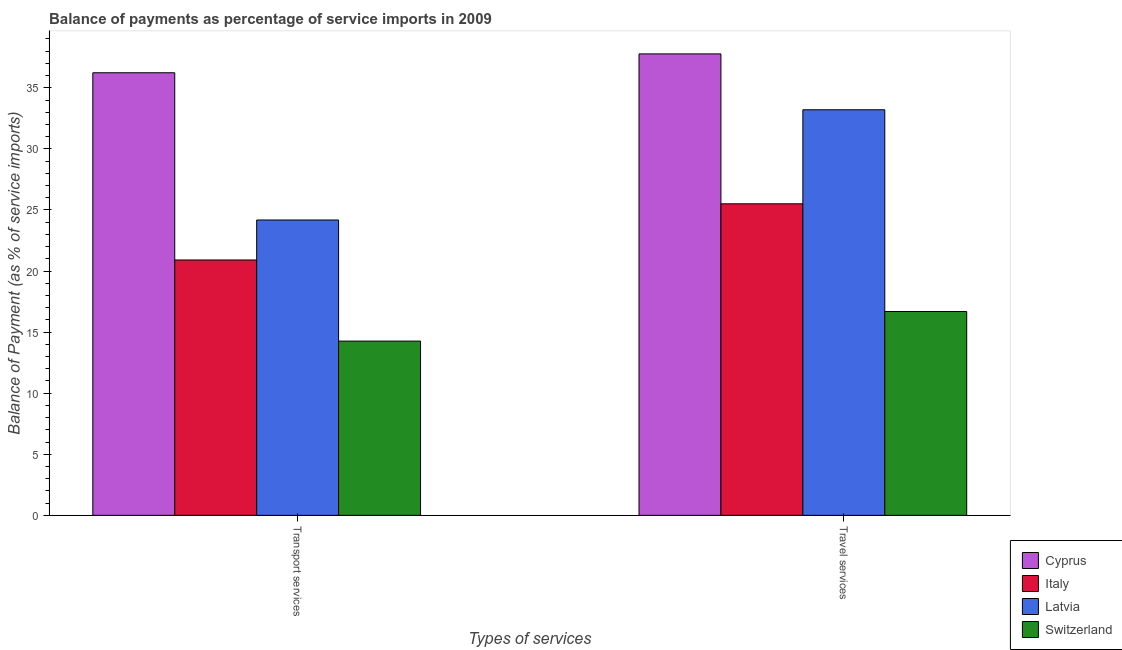How many different coloured bars are there?
Give a very brief answer. 4. How many groups of bars are there?
Ensure brevity in your answer.  2. Are the number of bars per tick equal to the number of legend labels?
Make the answer very short. Yes. How many bars are there on the 2nd tick from the right?
Your response must be concise. 4. What is the label of the 1st group of bars from the left?
Your response must be concise. Transport services. What is the balance of payments of transport services in Latvia?
Ensure brevity in your answer.  24.18. Across all countries, what is the maximum balance of payments of transport services?
Offer a very short reply. 36.23. Across all countries, what is the minimum balance of payments of transport services?
Your answer should be compact. 14.27. In which country was the balance of payments of transport services maximum?
Provide a short and direct response. Cyprus. In which country was the balance of payments of transport services minimum?
Ensure brevity in your answer.  Switzerland. What is the total balance of payments of travel services in the graph?
Offer a terse response. 113.17. What is the difference between the balance of payments of transport services in Latvia and that in Cyprus?
Ensure brevity in your answer.  -12.05. What is the difference between the balance of payments of transport services in Cyprus and the balance of payments of travel services in Switzerland?
Keep it short and to the point. 19.55. What is the average balance of payments of transport services per country?
Your answer should be compact. 23.9. What is the difference between the balance of payments of travel services and balance of payments of transport services in Switzerland?
Give a very brief answer. 2.42. What is the ratio of the balance of payments of transport services in Italy to that in Switzerland?
Give a very brief answer. 1.47. In how many countries, is the balance of payments of travel services greater than the average balance of payments of travel services taken over all countries?
Your response must be concise. 2. What does the 3rd bar from the left in Travel services represents?
Offer a terse response. Latvia. What does the 4th bar from the right in Travel services represents?
Your answer should be compact. Cyprus. How many countries are there in the graph?
Provide a short and direct response. 4. What is the difference between two consecutive major ticks on the Y-axis?
Provide a succinct answer. 5. How are the legend labels stacked?
Provide a short and direct response. Vertical. What is the title of the graph?
Keep it short and to the point. Balance of payments as percentage of service imports in 2009. What is the label or title of the X-axis?
Offer a very short reply. Types of services. What is the label or title of the Y-axis?
Keep it short and to the point. Balance of Payment (as % of service imports). What is the Balance of Payment (as % of service imports) of Cyprus in Transport services?
Give a very brief answer. 36.23. What is the Balance of Payment (as % of service imports) of Italy in Transport services?
Your answer should be very brief. 20.91. What is the Balance of Payment (as % of service imports) in Latvia in Transport services?
Provide a short and direct response. 24.18. What is the Balance of Payment (as % of service imports) in Switzerland in Transport services?
Make the answer very short. 14.27. What is the Balance of Payment (as % of service imports) of Cyprus in Travel services?
Provide a short and direct response. 37.78. What is the Balance of Payment (as % of service imports) in Italy in Travel services?
Your answer should be compact. 25.5. What is the Balance of Payment (as % of service imports) of Latvia in Travel services?
Make the answer very short. 33.2. What is the Balance of Payment (as % of service imports) in Switzerland in Travel services?
Ensure brevity in your answer.  16.69. Across all Types of services, what is the maximum Balance of Payment (as % of service imports) of Cyprus?
Provide a short and direct response. 37.78. Across all Types of services, what is the maximum Balance of Payment (as % of service imports) of Italy?
Keep it short and to the point. 25.5. Across all Types of services, what is the maximum Balance of Payment (as % of service imports) in Latvia?
Ensure brevity in your answer.  33.2. Across all Types of services, what is the maximum Balance of Payment (as % of service imports) of Switzerland?
Provide a short and direct response. 16.69. Across all Types of services, what is the minimum Balance of Payment (as % of service imports) of Cyprus?
Make the answer very short. 36.23. Across all Types of services, what is the minimum Balance of Payment (as % of service imports) in Italy?
Offer a very short reply. 20.91. Across all Types of services, what is the minimum Balance of Payment (as % of service imports) of Latvia?
Make the answer very short. 24.18. Across all Types of services, what is the minimum Balance of Payment (as % of service imports) of Switzerland?
Provide a short and direct response. 14.27. What is the total Balance of Payment (as % of service imports) of Cyprus in the graph?
Provide a short and direct response. 74.01. What is the total Balance of Payment (as % of service imports) in Italy in the graph?
Your answer should be very brief. 46.41. What is the total Balance of Payment (as % of service imports) in Latvia in the graph?
Make the answer very short. 57.38. What is the total Balance of Payment (as % of service imports) of Switzerland in the graph?
Provide a short and direct response. 30.95. What is the difference between the Balance of Payment (as % of service imports) of Cyprus in Transport services and that in Travel services?
Provide a succinct answer. -1.54. What is the difference between the Balance of Payment (as % of service imports) in Italy in Transport services and that in Travel services?
Your response must be concise. -4.6. What is the difference between the Balance of Payment (as % of service imports) of Latvia in Transport services and that in Travel services?
Offer a terse response. -9.02. What is the difference between the Balance of Payment (as % of service imports) in Switzerland in Transport services and that in Travel services?
Provide a succinct answer. -2.42. What is the difference between the Balance of Payment (as % of service imports) of Cyprus in Transport services and the Balance of Payment (as % of service imports) of Italy in Travel services?
Provide a short and direct response. 10.73. What is the difference between the Balance of Payment (as % of service imports) of Cyprus in Transport services and the Balance of Payment (as % of service imports) of Latvia in Travel services?
Offer a terse response. 3.03. What is the difference between the Balance of Payment (as % of service imports) of Cyprus in Transport services and the Balance of Payment (as % of service imports) of Switzerland in Travel services?
Give a very brief answer. 19.55. What is the difference between the Balance of Payment (as % of service imports) of Italy in Transport services and the Balance of Payment (as % of service imports) of Latvia in Travel services?
Give a very brief answer. -12.3. What is the difference between the Balance of Payment (as % of service imports) of Italy in Transport services and the Balance of Payment (as % of service imports) of Switzerland in Travel services?
Provide a succinct answer. 4.22. What is the difference between the Balance of Payment (as % of service imports) of Latvia in Transport services and the Balance of Payment (as % of service imports) of Switzerland in Travel services?
Offer a very short reply. 7.49. What is the average Balance of Payment (as % of service imports) of Cyprus per Types of services?
Make the answer very short. 37.01. What is the average Balance of Payment (as % of service imports) of Italy per Types of services?
Your response must be concise. 23.21. What is the average Balance of Payment (as % of service imports) of Latvia per Types of services?
Give a very brief answer. 28.69. What is the average Balance of Payment (as % of service imports) of Switzerland per Types of services?
Your answer should be compact. 15.48. What is the difference between the Balance of Payment (as % of service imports) in Cyprus and Balance of Payment (as % of service imports) in Italy in Transport services?
Give a very brief answer. 15.33. What is the difference between the Balance of Payment (as % of service imports) of Cyprus and Balance of Payment (as % of service imports) of Latvia in Transport services?
Make the answer very short. 12.05. What is the difference between the Balance of Payment (as % of service imports) of Cyprus and Balance of Payment (as % of service imports) of Switzerland in Transport services?
Provide a succinct answer. 21.97. What is the difference between the Balance of Payment (as % of service imports) of Italy and Balance of Payment (as % of service imports) of Latvia in Transport services?
Your answer should be compact. -3.27. What is the difference between the Balance of Payment (as % of service imports) of Italy and Balance of Payment (as % of service imports) of Switzerland in Transport services?
Ensure brevity in your answer.  6.64. What is the difference between the Balance of Payment (as % of service imports) in Latvia and Balance of Payment (as % of service imports) in Switzerland in Transport services?
Your response must be concise. 9.91. What is the difference between the Balance of Payment (as % of service imports) of Cyprus and Balance of Payment (as % of service imports) of Italy in Travel services?
Your answer should be compact. 12.27. What is the difference between the Balance of Payment (as % of service imports) of Cyprus and Balance of Payment (as % of service imports) of Latvia in Travel services?
Make the answer very short. 4.58. What is the difference between the Balance of Payment (as % of service imports) in Cyprus and Balance of Payment (as % of service imports) in Switzerland in Travel services?
Provide a succinct answer. 21.09. What is the difference between the Balance of Payment (as % of service imports) in Italy and Balance of Payment (as % of service imports) in Latvia in Travel services?
Your answer should be very brief. -7.7. What is the difference between the Balance of Payment (as % of service imports) in Italy and Balance of Payment (as % of service imports) in Switzerland in Travel services?
Provide a short and direct response. 8.82. What is the difference between the Balance of Payment (as % of service imports) in Latvia and Balance of Payment (as % of service imports) in Switzerland in Travel services?
Provide a short and direct response. 16.52. What is the ratio of the Balance of Payment (as % of service imports) of Cyprus in Transport services to that in Travel services?
Ensure brevity in your answer.  0.96. What is the ratio of the Balance of Payment (as % of service imports) of Italy in Transport services to that in Travel services?
Ensure brevity in your answer.  0.82. What is the ratio of the Balance of Payment (as % of service imports) in Latvia in Transport services to that in Travel services?
Ensure brevity in your answer.  0.73. What is the ratio of the Balance of Payment (as % of service imports) in Switzerland in Transport services to that in Travel services?
Ensure brevity in your answer.  0.85. What is the difference between the highest and the second highest Balance of Payment (as % of service imports) in Cyprus?
Make the answer very short. 1.54. What is the difference between the highest and the second highest Balance of Payment (as % of service imports) in Italy?
Provide a short and direct response. 4.6. What is the difference between the highest and the second highest Balance of Payment (as % of service imports) in Latvia?
Provide a short and direct response. 9.02. What is the difference between the highest and the second highest Balance of Payment (as % of service imports) of Switzerland?
Give a very brief answer. 2.42. What is the difference between the highest and the lowest Balance of Payment (as % of service imports) of Cyprus?
Provide a short and direct response. 1.54. What is the difference between the highest and the lowest Balance of Payment (as % of service imports) in Italy?
Provide a succinct answer. 4.6. What is the difference between the highest and the lowest Balance of Payment (as % of service imports) of Latvia?
Your answer should be compact. 9.02. What is the difference between the highest and the lowest Balance of Payment (as % of service imports) in Switzerland?
Provide a succinct answer. 2.42. 